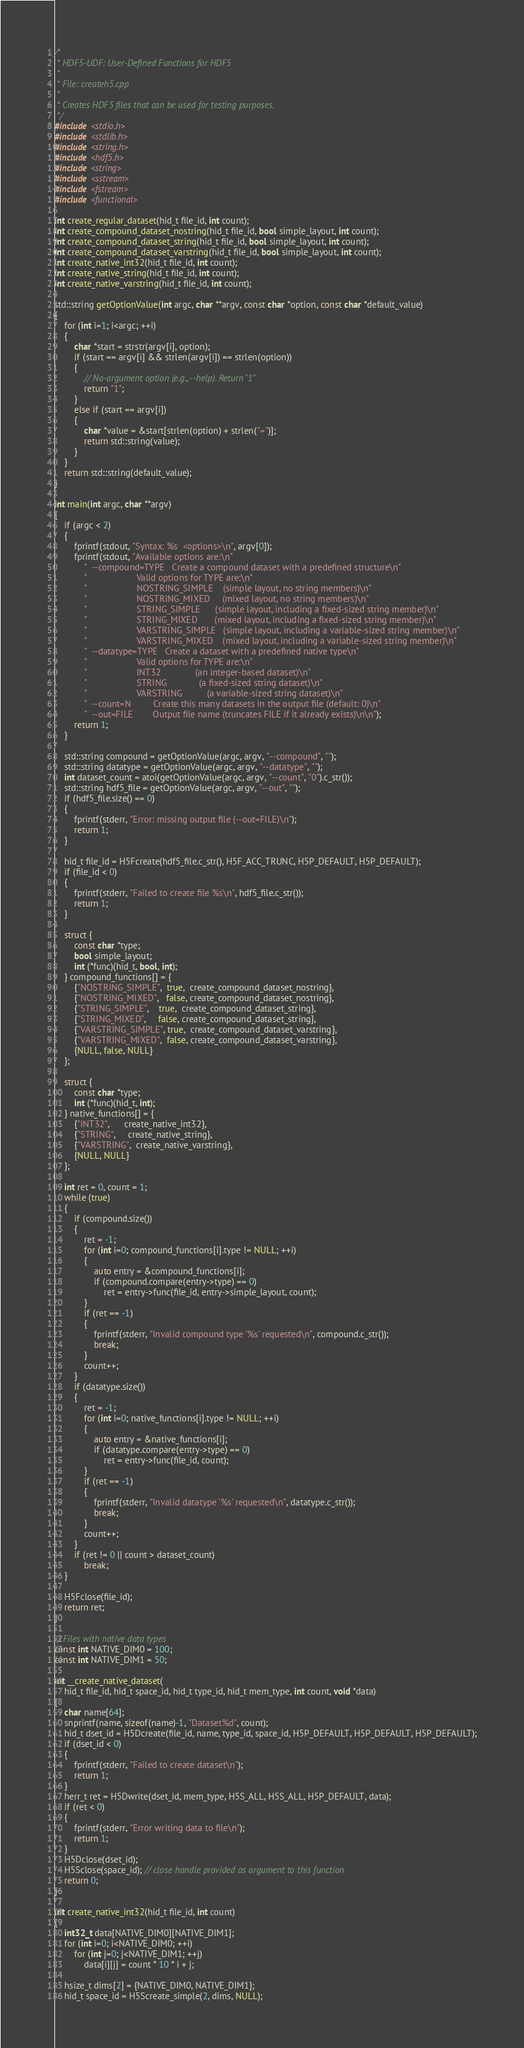<code> <loc_0><loc_0><loc_500><loc_500><_C++_>/*
 * HDF5-UDF: User-Defined Functions for HDF5
 *
 * File: createh5.cpp
 *
 * Creates HDF5 files that can be used for testing purposes.
 */
#include <stdio.h>
#include <stdlib.h>
#include <string.h>
#include <hdf5.h>
#include <string>
#include <sstream>
#include <fstream>
#include <functional>

int create_regular_dataset(hid_t file_id, int count);
int create_compound_dataset_nostring(hid_t file_id, bool simple_layout, int count);
int create_compound_dataset_string(hid_t file_id, bool simple_layout, int count);
int create_compound_dataset_varstring(hid_t file_id, bool simple_layout, int count);
int create_native_int32(hid_t file_id, int count);
int create_native_string(hid_t file_id, int count);
int create_native_varstring(hid_t file_id, int count);

std::string getOptionValue(int argc, char **argv, const char *option, const char *default_value)
{
    for (int i=1; i<argc; ++i)
    {
        char *start = strstr(argv[i], option);
        if (start == argv[i] && strlen(argv[i]) == strlen(option))
        {
            // No-argument option (e.g., --help). Return "1"
            return "1";
        }
        else if (start == argv[i])
        {
            char *value = &start[strlen(option) + strlen("=")];
            return std::string(value);
        }
    }
    return std::string(default_value);
}

int main(int argc, char **argv)
{
    if (argc < 2)
    {
        fprintf(stdout, "Syntax: %s  <options>\n", argv[0]);
        fprintf(stdout, "Available options are:\n"
            "  --compound=TYPE   Create a compound dataset with a predefined structure\n"
            "                    Valid options for TYPE are:\n"
            "                    NOSTRING_SIMPLE    (simple layout, no string members)\n"
            "                    NOSTRING_MIXED     (mixed layout, no string members)\n"
            "                    STRING_SIMPLE      (simple layout, including a fixed-sized string member)\n"
            "                    STRING_MIXED       (mixed layout, including a fixed-sized string member)\n"
            "                    VARSTRING_SIMPLE   (simple layout, including a variable-sized string member)\n"
            "                    VARSTRING_MIXED    (mixed layout, including a variable-sized string member)\n"
            "  --datatype=TYPE   Create a dataset with a predefined native type\n"
            "                    Valid options for TYPE are:\n"
            "                    INT32              (an integer-based dataset)\n"
            "                    STRING             (a fixed-sized string dataset)\n"
            "                    VARSTRING          (a variable-sized string dataset)\n"
            "  --count=N         Create this many datasets in the output file (default: 0)\n"
            "  --out=FILE        Output file name (truncates FILE if it already exists)\n\n");
        return 1;
    }

    std::string compound = getOptionValue(argc, argv, "--compound", "");
    std::string datatype = getOptionValue(argc, argv, "--datatype", "");
    int dataset_count = atoi(getOptionValue(argc, argv, "--count", "0").c_str());
    std::string hdf5_file = getOptionValue(argc, argv, "--out", "");
    if (hdf5_file.size() == 0)
    {
        fprintf(stderr, "Error: missing output file (--out=FILE)\n");
        return 1;
    }

    hid_t file_id = H5Fcreate(hdf5_file.c_str(), H5F_ACC_TRUNC, H5P_DEFAULT, H5P_DEFAULT);
    if (file_id < 0)
    {
        fprintf(stderr, "Failed to create file %s\n", hdf5_file.c_str());
        return 1;
    }

    struct {
        const char *type;
        bool simple_layout;
        int (*func)(hid_t, bool, int);
    } compound_functions[] = {
        {"NOSTRING_SIMPLE",  true,  create_compound_dataset_nostring},
        {"NOSTRING_MIXED",   false, create_compound_dataset_nostring},
        {"STRING_SIMPLE",    true,  create_compound_dataset_string},
        {"STRING_MIXED",     false, create_compound_dataset_string},
        {"VARSTRING_SIMPLE", true,  create_compound_dataset_varstring},
        {"VARSTRING_MIXED",  false, create_compound_dataset_varstring},
        {NULL, false, NULL}
    };

    struct {
        const char *type;
        int (*func)(hid_t, int);
    } native_functions[] = {
        {"INT32",      create_native_int32},
        {"STRING",     create_native_string},
        {"VARSTRING",  create_native_varstring},
        {NULL, NULL}
    };

    int ret = 0, count = 1;
    while (true)
    {
        if (compound.size())
        {
            ret = -1;
            for (int i=0; compound_functions[i].type != NULL; ++i)
            {
                auto entry = &compound_functions[i];
                if (compound.compare(entry->type) == 0)
                    ret = entry->func(file_id, entry->simple_layout, count);
            }
            if (ret == -1)
            {
                fprintf(stderr, "Invalid compound type '%s' requested\n", compound.c_str());
                break;
            }
            count++;
        }
        if (datatype.size())
        {
            ret = -1;
            for (int i=0; native_functions[i].type != NULL; ++i)
            {
                auto entry = &native_functions[i];
                if (datatype.compare(entry->type) == 0)
                    ret = entry->func(file_id, count);
            }
            if (ret == -1)
            {
                fprintf(stderr, "Invalid datatype '%s' requested\n", datatype.c_str());
                break;
            }
            count++;
        }
        if (ret != 0 || count > dataset_count)
            break;
    }

    H5Fclose(file_id);
    return ret;
}

// Files with native data types
const int NATIVE_DIM0 = 100;
const int NATIVE_DIM1 = 50;

int __create_native_dataset(
    hid_t file_id, hid_t space_id, hid_t type_id, hid_t mem_type, int count, void *data)
{
    char name[64];
    snprintf(name, sizeof(name)-1, "Dataset%d", count);
    hid_t dset_id = H5Dcreate(file_id, name, type_id, space_id, H5P_DEFAULT, H5P_DEFAULT, H5P_DEFAULT);
    if (dset_id < 0)
    {
        fprintf(stderr, "Failed to create dataset\n");
        return 1;
    }
    herr_t ret = H5Dwrite(dset_id, mem_type, H5S_ALL, H5S_ALL, H5P_DEFAULT, data);
    if (ret < 0)
    {
        fprintf(stderr, "Error writing data to file\n");
        return 1;
    }
    H5Dclose(dset_id);
    H5Sclose(space_id); // close handle provided as argument to this function
    return 0;
}

int create_native_int32(hid_t file_id, int count)
{
    int32_t data[NATIVE_DIM0][NATIVE_DIM1];
    for (int i=0; i<NATIVE_DIM0; ++i)
        for (int j=0; j<NATIVE_DIM1; ++j)
            data[i][j] = count * 10 * i + j;

    hsize_t dims[2] = {NATIVE_DIM0, NATIVE_DIM1};
    hid_t space_id = H5Screate_simple(2, dims, NULL);</code> 